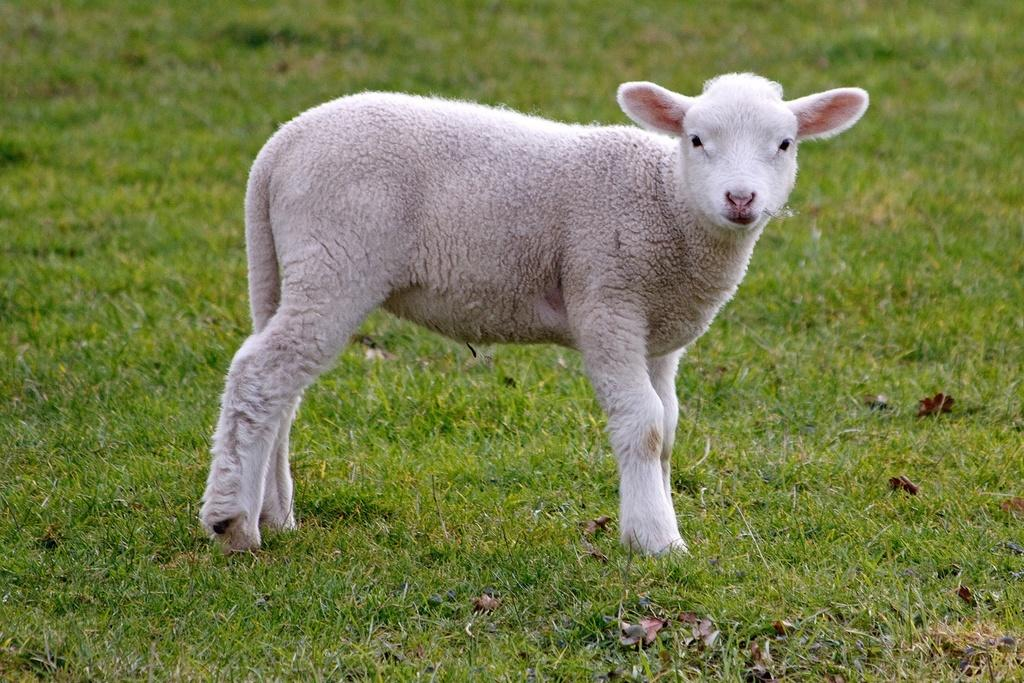What animal is present in the image? There is a sheep in the image. What is the sheep standing on? The sheep is standing on the grass. What invention can be seen in the image? There is no invention present in the image; it features a sheep standing on the grass. How many hens are visible in the image? There are no hens present in the image; it features a sheep standing on the grass. 